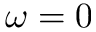<formula> <loc_0><loc_0><loc_500><loc_500>\omega = 0</formula> 